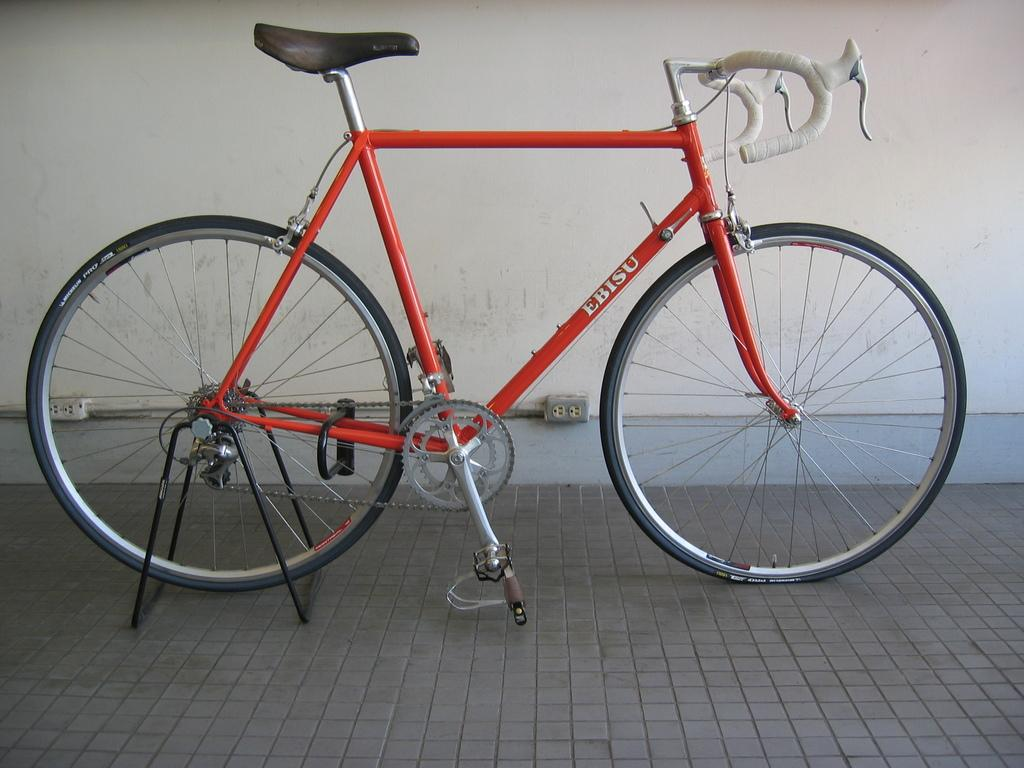What is the main subject of the image? The main subject of the image is a bicycle. Where is the bicycle located in the image? The bicycle is in the center of the image. What type of substance is causing the crack in the bicycle's frame in the image? There is no crack or substance present in the image; the bicycle appears to be in good condition. 